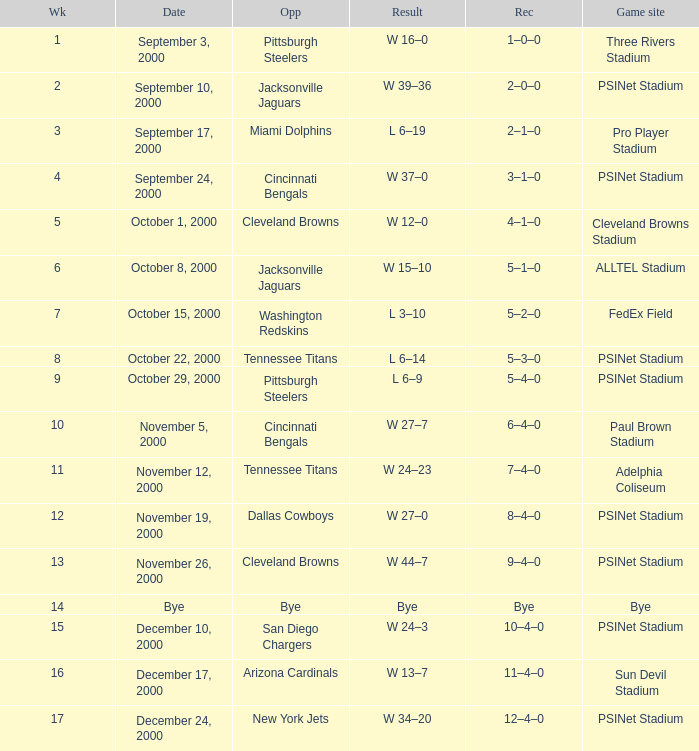What's the result at psinet stadium when the cincinnati bengals are the opponent? W 37–0. 